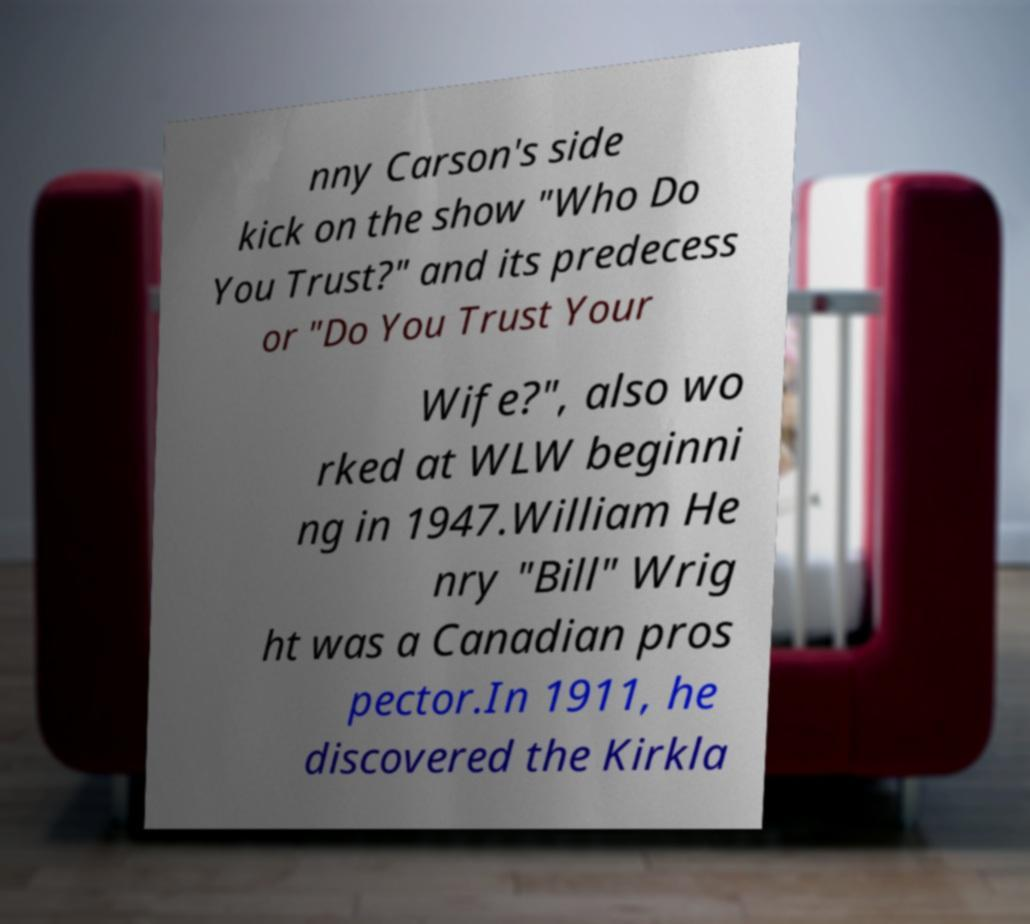Could you extract and type out the text from this image? nny Carson's side kick on the show "Who Do You Trust?" and its predecess or "Do You Trust Your Wife?", also wo rked at WLW beginni ng in 1947.William He nry "Bill" Wrig ht was a Canadian pros pector.In 1911, he discovered the Kirkla 